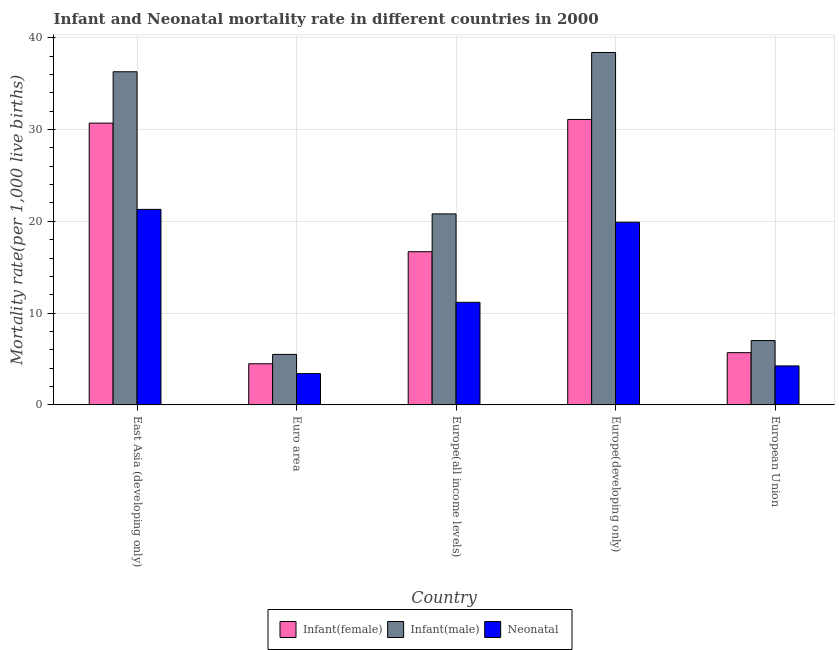Are the number of bars per tick equal to the number of legend labels?
Provide a succinct answer. Yes. Are the number of bars on each tick of the X-axis equal?
Your answer should be compact. Yes. How many bars are there on the 4th tick from the left?
Offer a very short reply. 3. How many bars are there on the 3rd tick from the right?
Make the answer very short. 3. What is the label of the 2nd group of bars from the left?
Your answer should be very brief. Euro area. What is the neonatal mortality rate in Euro area?
Your response must be concise. 3.4. Across all countries, what is the maximum infant mortality rate(female)?
Make the answer very short. 31.1. Across all countries, what is the minimum neonatal mortality rate?
Give a very brief answer. 3.4. In which country was the neonatal mortality rate maximum?
Offer a very short reply. East Asia (developing only). In which country was the infant mortality rate(male) minimum?
Provide a short and direct response. Euro area. What is the total infant mortality rate(female) in the graph?
Ensure brevity in your answer.  88.64. What is the difference between the infant mortality rate(female) in Euro area and that in Europe(developing only)?
Ensure brevity in your answer.  -26.63. What is the difference between the neonatal mortality rate in Euro area and the infant mortality rate(male) in East Asia (developing only)?
Ensure brevity in your answer.  -32.9. What is the average neonatal mortality rate per country?
Provide a short and direct response. 12. What is the difference between the infant mortality rate(female) and infant mortality rate(male) in Euro area?
Your answer should be compact. -1.02. What is the ratio of the infant mortality rate(female) in East Asia (developing only) to that in European Union?
Make the answer very short. 5.4. Is the difference between the neonatal mortality rate in Euro area and Europe(developing only) greater than the difference between the infant mortality rate(male) in Euro area and Europe(developing only)?
Keep it short and to the point. Yes. What is the difference between the highest and the second highest neonatal mortality rate?
Make the answer very short. 1.4. What is the difference between the highest and the lowest neonatal mortality rate?
Give a very brief answer. 17.9. What does the 3rd bar from the left in Euro area represents?
Provide a short and direct response. Neonatal . What does the 3rd bar from the right in Europe(all income levels) represents?
Your answer should be very brief. Infant(female). Is it the case that in every country, the sum of the infant mortality rate(female) and infant mortality rate(male) is greater than the neonatal mortality rate?
Give a very brief answer. Yes. How many bars are there?
Your response must be concise. 15. What is the difference between two consecutive major ticks on the Y-axis?
Your response must be concise. 10. Are the values on the major ticks of Y-axis written in scientific E-notation?
Give a very brief answer. No. Does the graph contain any zero values?
Ensure brevity in your answer.  No. Does the graph contain grids?
Your answer should be compact. Yes. Where does the legend appear in the graph?
Ensure brevity in your answer.  Bottom center. How many legend labels are there?
Give a very brief answer. 3. What is the title of the graph?
Give a very brief answer. Infant and Neonatal mortality rate in different countries in 2000. What is the label or title of the X-axis?
Offer a terse response. Country. What is the label or title of the Y-axis?
Provide a succinct answer. Mortality rate(per 1,0 live births). What is the Mortality rate(per 1,000 live births) in Infant(female) in East Asia (developing only)?
Offer a very short reply. 30.7. What is the Mortality rate(per 1,000 live births) in Infant(male) in East Asia (developing only)?
Provide a succinct answer. 36.3. What is the Mortality rate(per 1,000 live births) of Neonatal  in East Asia (developing only)?
Offer a very short reply. 21.3. What is the Mortality rate(per 1,000 live births) in Infant(female) in Euro area?
Make the answer very short. 4.47. What is the Mortality rate(per 1,000 live births) of Infant(male) in Euro area?
Your response must be concise. 5.5. What is the Mortality rate(per 1,000 live births) in Neonatal  in Euro area?
Keep it short and to the point. 3.4. What is the Mortality rate(per 1,000 live births) in Infant(female) in Europe(all income levels)?
Ensure brevity in your answer.  16.69. What is the Mortality rate(per 1,000 live births) of Infant(male) in Europe(all income levels)?
Your answer should be compact. 20.81. What is the Mortality rate(per 1,000 live births) of Neonatal  in Europe(all income levels)?
Offer a very short reply. 11.17. What is the Mortality rate(per 1,000 live births) of Infant(female) in Europe(developing only)?
Offer a terse response. 31.1. What is the Mortality rate(per 1,000 live births) in Infant(male) in Europe(developing only)?
Your answer should be compact. 38.4. What is the Mortality rate(per 1,000 live births) of Infant(female) in European Union?
Your answer should be very brief. 5.68. What is the Mortality rate(per 1,000 live births) in Infant(male) in European Union?
Your answer should be very brief. 7. What is the Mortality rate(per 1,000 live births) in Neonatal  in European Union?
Provide a succinct answer. 4.24. Across all countries, what is the maximum Mortality rate(per 1,000 live births) of Infant(female)?
Offer a very short reply. 31.1. Across all countries, what is the maximum Mortality rate(per 1,000 live births) in Infant(male)?
Your answer should be compact. 38.4. Across all countries, what is the maximum Mortality rate(per 1,000 live births) of Neonatal ?
Provide a succinct answer. 21.3. Across all countries, what is the minimum Mortality rate(per 1,000 live births) in Infant(female)?
Make the answer very short. 4.47. Across all countries, what is the minimum Mortality rate(per 1,000 live births) of Infant(male)?
Your answer should be very brief. 5.5. Across all countries, what is the minimum Mortality rate(per 1,000 live births) of Neonatal ?
Keep it short and to the point. 3.4. What is the total Mortality rate(per 1,000 live births) in Infant(female) in the graph?
Make the answer very short. 88.64. What is the total Mortality rate(per 1,000 live births) of Infant(male) in the graph?
Your response must be concise. 108. What is the total Mortality rate(per 1,000 live births) of Neonatal  in the graph?
Offer a terse response. 60.01. What is the difference between the Mortality rate(per 1,000 live births) in Infant(female) in East Asia (developing only) and that in Euro area?
Make the answer very short. 26.23. What is the difference between the Mortality rate(per 1,000 live births) of Infant(male) in East Asia (developing only) and that in Euro area?
Keep it short and to the point. 30.8. What is the difference between the Mortality rate(per 1,000 live births) of Neonatal  in East Asia (developing only) and that in Euro area?
Ensure brevity in your answer.  17.9. What is the difference between the Mortality rate(per 1,000 live births) in Infant(female) in East Asia (developing only) and that in Europe(all income levels)?
Ensure brevity in your answer.  14.01. What is the difference between the Mortality rate(per 1,000 live births) of Infant(male) in East Asia (developing only) and that in Europe(all income levels)?
Your answer should be very brief. 15.49. What is the difference between the Mortality rate(per 1,000 live births) in Neonatal  in East Asia (developing only) and that in Europe(all income levels)?
Offer a terse response. 10.13. What is the difference between the Mortality rate(per 1,000 live births) of Infant(female) in East Asia (developing only) and that in Europe(developing only)?
Offer a very short reply. -0.4. What is the difference between the Mortality rate(per 1,000 live births) of Infant(female) in East Asia (developing only) and that in European Union?
Keep it short and to the point. 25.02. What is the difference between the Mortality rate(per 1,000 live births) in Infant(male) in East Asia (developing only) and that in European Union?
Your response must be concise. 29.3. What is the difference between the Mortality rate(per 1,000 live births) of Neonatal  in East Asia (developing only) and that in European Union?
Your answer should be very brief. 17.06. What is the difference between the Mortality rate(per 1,000 live births) of Infant(female) in Euro area and that in Europe(all income levels)?
Provide a short and direct response. -12.21. What is the difference between the Mortality rate(per 1,000 live births) in Infant(male) in Euro area and that in Europe(all income levels)?
Provide a short and direct response. -15.31. What is the difference between the Mortality rate(per 1,000 live births) of Neonatal  in Euro area and that in Europe(all income levels)?
Your answer should be compact. -7.77. What is the difference between the Mortality rate(per 1,000 live births) of Infant(female) in Euro area and that in Europe(developing only)?
Provide a succinct answer. -26.63. What is the difference between the Mortality rate(per 1,000 live births) in Infant(male) in Euro area and that in Europe(developing only)?
Provide a short and direct response. -32.9. What is the difference between the Mortality rate(per 1,000 live births) in Neonatal  in Euro area and that in Europe(developing only)?
Provide a succinct answer. -16.5. What is the difference between the Mortality rate(per 1,000 live births) in Infant(female) in Euro area and that in European Union?
Make the answer very short. -1.21. What is the difference between the Mortality rate(per 1,000 live births) in Infant(male) in Euro area and that in European Union?
Keep it short and to the point. -1.51. What is the difference between the Mortality rate(per 1,000 live births) in Neonatal  in Euro area and that in European Union?
Provide a succinct answer. -0.84. What is the difference between the Mortality rate(per 1,000 live births) of Infant(female) in Europe(all income levels) and that in Europe(developing only)?
Your response must be concise. -14.41. What is the difference between the Mortality rate(per 1,000 live births) in Infant(male) in Europe(all income levels) and that in Europe(developing only)?
Keep it short and to the point. -17.59. What is the difference between the Mortality rate(per 1,000 live births) of Neonatal  in Europe(all income levels) and that in Europe(developing only)?
Give a very brief answer. -8.73. What is the difference between the Mortality rate(per 1,000 live births) of Infant(female) in Europe(all income levels) and that in European Union?
Keep it short and to the point. 11. What is the difference between the Mortality rate(per 1,000 live births) of Infant(male) in Europe(all income levels) and that in European Union?
Offer a very short reply. 13.8. What is the difference between the Mortality rate(per 1,000 live births) of Neonatal  in Europe(all income levels) and that in European Union?
Your answer should be very brief. 6.93. What is the difference between the Mortality rate(per 1,000 live births) of Infant(female) in Europe(developing only) and that in European Union?
Ensure brevity in your answer.  25.42. What is the difference between the Mortality rate(per 1,000 live births) of Infant(male) in Europe(developing only) and that in European Union?
Offer a terse response. 31.4. What is the difference between the Mortality rate(per 1,000 live births) in Neonatal  in Europe(developing only) and that in European Union?
Your answer should be very brief. 15.66. What is the difference between the Mortality rate(per 1,000 live births) of Infant(female) in East Asia (developing only) and the Mortality rate(per 1,000 live births) of Infant(male) in Euro area?
Your response must be concise. 25.2. What is the difference between the Mortality rate(per 1,000 live births) in Infant(female) in East Asia (developing only) and the Mortality rate(per 1,000 live births) in Neonatal  in Euro area?
Make the answer very short. 27.3. What is the difference between the Mortality rate(per 1,000 live births) in Infant(male) in East Asia (developing only) and the Mortality rate(per 1,000 live births) in Neonatal  in Euro area?
Offer a very short reply. 32.9. What is the difference between the Mortality rate(per 1,000 live births) of Infant(female) in East Asia (developing only) and the Mortality rate(per 1,000 live births) of Infant(male) in Europe(all income levels)?
Offer a terse response. 9.89. What is the difference between the Mortality rate(per 1,000 live births) in Infant(female) in East Asia (developing only) and the Mortality rate(per 1,000 live births) in Neonatal  in Europe(all income levels)?
Give a very brief answer. 19.53. What is the difference between the Mortality rate(per 1,000 live births) in Infant(male) in East Asia (developing only) and the Mortality rate(per 1,000 live births) in Neonatal  in Europe(all income levels)?
Provide a short and direct response. 25.13. What is the difference between the Mortality rate(per 1,000 live births) in Infant(female) in East Asia (developing only) and the Mortality rate(per 1,000 live births) in Neonatal  in Europe(developing only)?
Make the answer very short. 10.8. What is the difference between the Mortality rate(per 1,000 live births) in Infant(female) in East Asia (developing only) and the Mortality rate(per 1,000 live births) in Infant(male) in European Union?
Keep it short and to the point. 23.7. What is the difference between the Mortality rate(per 1,000 live births) of Infant(female) in East Asia (developing only) and the Mortality rate(per 1,000 live births) of Neonatal  in European Union?
Ensure brevity in your answer.  26.46. What is the difference between the Mortality rate(per 1,000 live births) in Infant(male) in East Asia (developing only) and the Mortality rate(per 1,000 live births) in Neonatal  in European Union?
Ensure brevity in your answer.  32.06. What is the difference between the Mortality rate(per 1,000 live births) in Infant(female) in Euro area and the Mortality rate(per 1,000 live births) in Infant(male) in Europe(all income levels)?
Your answer should be very brief. -16.33. What is the difference between the Mortality rate(per 1,000 live births) in Infant(female) in Euro area and the Mortality rate(per 1,000 live births) in Neonatal  in Europe(all income levels)?
Your answer should be very brief. -6.7. What is the difference between the Mortality rate(per 1,000 live births) in Infant(male) in Euro area and the Mortality rate(per 1,000 live births) in Neonatal  in Europe(all income levels)?
Offer a terse response. -5.67. What is the difference between the Mortality rate(per 1,000 live births) of Infant(female) in Euro area and the Mortality rate(per 1,000 live births) of Infant(male) in Europe(developing only)?
Your answer should be compact. -33.93. What is the difference between the Mortality rate(per 1,000 live births) of Infant(female) in Euro area and the Mortality rate(per 1,000 live births) of Neonatal  in Europe(developing only)?
Make the answer very short. -15.43. What is the difference between the Mortality rate(per 1,000 live births) of Infant(male) in Euro area and the Mortality rate(per 1,000 live births) of Neonatal  in Europe(developing only)?
Your answer should be compact. -14.4. What is the difference between the Mortality rate(per 1,000 live births) in Infant(female) in Euro area and the Mortality rate(per 1,000 live births) in Infant(male) in European Union?
Give a very brief answer. -2.53. What is the difference between the Mortality rate(per 1,000 live births) of Infant(female) in Euro area and the Mortality rate(per 1,000 live births) of Neonatal  in European Union?
Ensure brevity in your answer.  0.23. What is the difference between the Mortality rate(per 1,000 live births) of Infant(male) in Euro area and the Mortality rate(per 1,000 live births) of Neonatal  in European Union?
Keep it short and to the point. 1.26. What is the difference between the Mortality rate(per 1,000 live births) of Infant(female) in Europe(all income levels) and the Mortality rate(per 1,000 live births) of Infant(male) in Europe(developing only)?
Ensure brevity in your answer.  -21.71. What is the difference between the Mortality rate(per 1,000 live births) in Infant(female) in Europe(all income levels) and the Mortality rate(per 1,000 live births) in Neonatal  in Europe(developing only)?
Your answer should be very brief. -3.21. What is the difference between the Mortality rate(per 1,000 live births) in Infant(male) in Europe(all income levels) and the Mortality rate(per 1,000 live births) in Neonatal  in Europe(developing only)?
Ensure brevity in your answer.  0.91. What is the difference between the Mortality rate(per 1,000 live births) of Infant(female) in Europe(all income levels) and the Mortality rate(per 1,000 live births) of Infant(male) in European Union?
Offer a terse response. 9.68. What is the difference between the Mortality rate(per 1,000 live births) of Infant(female) in Europe(all income levels) and the Mortality rate(per 1,000 live births) of Neonatal  in European Union?
Give a very brief answer. 12.45. What is the difference between the Mortality rate(per 1,000 live births) of Infant(male) in Europe(all income levels) and the Mortality rate(per 1,000 live births) of Neonatal  in European Union?
Give a very brief answer. 16.57. What is the difference between the Mortality rate(per 1,000 live births) in Infant(female) in Europe(developing only) and the Mortality rate(per 1,000 live births) in Infant(male) in European Union?
Offer a very short reply. 24.1. What is the difference between the Mortality rate(per 1,000 live births) of Infant(female) in Europe(developing only) and the Mortality rate(per 1,000 live births) of Neonatal  in European Union?
Ensure brevity in your answer.  26.86. What is the difference between the Mortality rate(per 1,000 live births) in Infant(male) in Europe(developing only) and the Mortality rate(per 1,000 live births) in Neonatal  in European Union?
Give a very brief answer. 34.16. What is the average Mortality rate(per 1,000 live births) in Infant(female) per country?
Your response must be concise. 17.73. What is the average Mortality rate(per 1,000 live births) in Infant(male) per country?
Provide a succinct answer. 21.6. What is the average Mortality rate(per 1,000 live births) in Neonatal  per country?
Provide a short and direct response. 12. What is the difference between the Mortality rate(per 1,000 live births) of Infant(female) and Mortality rate(per 1,000 live births) of Neonatal  in East Asia (developing only)?
Make the answer very short. 9.4. What is the difference between the Mortality rate(per 1,000 live births) in Infant(female) and Mortality rate(per 1,000 live births) in Infant(male) in Euro area?
Give a very brief answer. -1.02. What is the difference between the Mortality rate(per 1,000 live births) in Infant(female) and Mortality rate(per 1,000 live births) in Neonatal  in Euro area?
Your answer should be very brief. 1.07. What is the difference between the Mortality rate(per 1,000 live births) of Infant(male) and Mortality rate(per 1,000 live births) of Neonatal  in Euro area?
Ensure brevity in your answer.  2.09. What is the difference between the Mortality rate(per 1,000 live births) in Infant(female) and Mortality rate(per 1,000 live births) in Infant(male) in Europe(all income levels)?
Your response must be concise. -4.12. What is the difference between the Mortality rate(per 1,000 live births) in Infant(female) and Mortality rate(per 1,000 live births) in Neonatal  in Europe(all income levels)?
Keep it short and to the point. 5.52. What is the difference between the Mortality rate(per 1,000 live births) in Infant(male) and Mortality rate(per 1,000 live births) in Neonatal  in Europe(all income levels)?
Offer a very short reply. 9.64. What is the difference between the Mortality rate(per 1,000 live births) in Infant(female) and Mortality rate(per 1,000 live births) in Infant(male) in Europe(developing only)?
Your response must be concise. -7.3. What is the difference between the Mortality rate(per 1,000 live births) in Infant(female) and Mortality rate(per 1,000 live births) in Neonatal  in Europe(developing only)?
Offer a very short reply. 11.2. What is the difference between the Mortality rate(per 1,000 live births) of Infant(female) and Mortality rate(per 1,000 live births) of Infant(male) in European Union?
Provide a short and direct response. -1.32. What is the difference between the Mortality rate(per 1,000 live births) in Infant(female) and Mortality rate(per 1,000 live births) in Neonatal  in European Union?
Offer a very short reply. 1.44. What is the difference between the Mortality rate(per 1,000 live births) of Infant(male) and Mortality rate(per 1,000 live births) of Neonatal  in European Union?
Your response must be concise. 2.76. What is the ratio of the Mortality rate(per 1,000 live births) of Infant(female) in East Asia (developing only) to that in Euro area?
Make the answer very short. 6.86. What is the ratio of the Mortality rate(per 1,000 live births) in Infant(male) in East Asia (developing only) to that in Euro area?
Make the answer very short. 6.61. What is the ratio of the Mortality rate(per 1,000 live births) in Neonatal  in East Asia (developing only) to that in Euro area?
Provide a succinct answer. 6.26. What is the ratio of the Mortality rate(per 1,000 live births) of Infant(female) in East Asia (developing only) to that in Europe(all income levels)?
Provide a short and direct response. 1.84. What is the ratio of the Mortality rate(per 1,000 live births) in Infant(male) in East Asia (developing only) to that in Europe(all income levels)?
Keep it short and to the point. 1.74. What is the ratio of the Mortality rate(per 1,000 live births) of Neonatal  in East Asia (developing only) to that in Europe(all income levels)?
Ensure brevity in your answer.  1.91. What is the ratio of the Mortality rate(per 1,000 live births) in Infant(female) in East Asia (developing only) to that in Europe(developing only)?
Ensure brevity in your answer.  0.99. What is the ratio of the Mortality rate(per 1,000 live births) in Infant(male) in East Asia (developing only) to that in Europe(developing only)?
Keep it short and to the point. 0.95. What is the ratio of the Mortality rate(per 1,000 live births) in Neonatal  in East Asia (developing only) to that in Europe(developing only)?
Give a very brief answer. 1.07. What is the ratio of the Mortality rate(per 1,000 live births) of Infant(female) in East Asia (developing only) to that in European Union?
Provide a succinct answer. 5.4. What is the ratio of the Mortality rate(per 1,000 live births) in Infant(male) in East Asia (developing only) to that in European Union?
Make the answer very short. 5.18. What is the ratio of the Mortality rate(per 1,000 live births) in Neonatal  in East Asia (developing only) to that in European Union?
Offer a very short reply. 5.03. What is the ratio of the Mortality rate(per 1,000 live births) in Infant(female) in Euro area to that in Europe(all income levels)?
Your answer should be compact. 0.27. What is the ratio of the Mortality rate(per 1,000 live births) in Infant(male) in Euro area to that in Europe(all income levels)?
Make the answer very short. 0.26. What is the ratio of the Mortality rate(per 1,000 live births) in Neonatal  in Euro area to that in Europe(all income levels)?
Your answer should be very brief. 0.3. What is the ratio of the Mortality rate(per 1,000 live births) of Infant(female) in Euro area to that in Europe(developing only)?
Ensure brevity in your answer.  0.14. What is the ratio of the Mortality rate(per 1,000 live births) of Infant(male) in Euro area to that in Europe(developing only)?
Offer a very short reply. 0.14. What is the ratio of the Mortality rate(per 1,000 live births) of Neonatal  in Euro area to that in Europe(developing only)?
Your answer should be very brief. 0.17. What is the ratio of the Mortality rate(per 1,000 live births) of Infant(female) in Euro area to that in European Union?
Your answer should be compact. 0.79. What is the ratio of the Mortality rate(per 1,000 live births) in Infant(male) in Euro area to that in European Union?
Ensure brevity in your answer.  0.78. What is the ratio of the Mortality rate(per 1,000 live births) in Neonatal  in Euro area to that in European Union?
Provide a succinct answer. 0.8. What is the ratio of the Mortality rate(per 1,000 live births) in Infant(female) in Europe(all income levels) to that in Europe(developing only)?
Your answer should be compact. 0.54. What is the ratio of the Mortality rate(per 1,000 live births) of Infant(male) in Europe(all income levels) to that in Europe(developing only)?
Make the answer very short. 0.54. What is the ratio of the Mortality rate(per 1,000 live births) of Neonatal  in Europe(all income levels) to that in Europe(developing only)?
Make the answer very short. 0.56. What is the ratio of the Mortality rate(per 1,000 live births) of Infant(female) in Europe(all income levels) to that in European Union?
Provide a short and direct response. 2.94. What is the ratio of the Mortality rate(per 1,000 live births) in Infant(male) in Europe(all income levels) to that in European Union?
Offer a terse response. 2.97. What is the ratio of the Mortality rate(per 1,000 live births) of Neonatal  in Europe(all income levels) to that in European Union?
Your answer should be very brief. 2.64. What is the ratio of the Mortality rate(per 1,000 live births) of Infant(female) in Europe(developing only) to that in European Union?
Offer a very short reply. 5.47. What is the ratio of the Mortality rate(per 1,000 live births) of Infant(male) in Europe(developing only) to that in European Union?
Your response must be concise. 5.48. What is the ratio of the Mortality rate(per 1,000 live births) in Neonatal  in Europe(developing only) to that in European Union?
Your response must be concise. 4.7. What is the difference between the highest and the second highest Mortality rate(per 1,000 live births) in Infant(female)?
Keep it short and to the point. 0.4. What is the difference between the highest and the second highest Mortality rate(per 1,000 live births) of Infant(male)?
Your response must be concise. 2.1. What is the difference between the highest and the second highest Mortality rate(per 1,000 live births) of Neonatal ?
Keep it short and to the point. 1.4. What is the difference between the highest and the lowest Mortality rate(per 1,000 live births) of Infant(female)?
Offer a terse response. 26.63. What is the difference between the highest and the lowest Mortality rate(per 1,000 live births) in Infant(male)?
Keep it short and to the point. 32.9. What is the difference between the highest and the lowest Mortality rate(per 1,000 live births) of Neonatal ?
Offer a terse response. 17.9. 